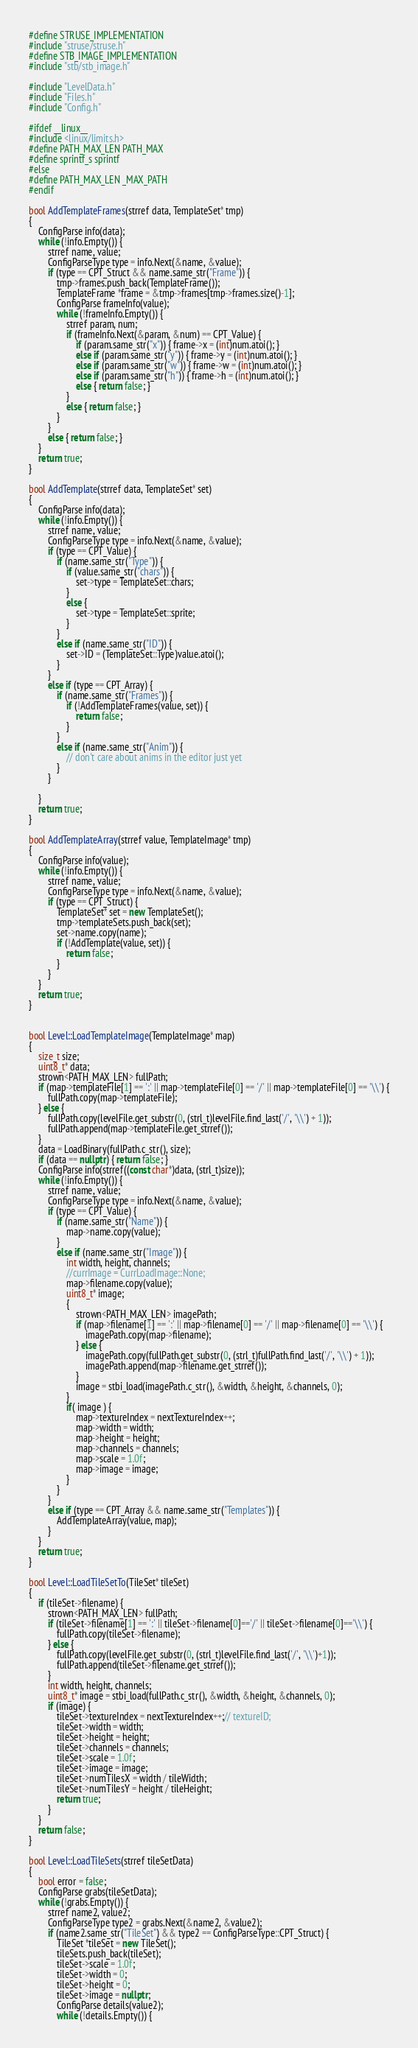<code> <loc_0><loc_0><loc_500><loc_500><_C++_>#define STRUSE_IMPLEMENTATION
#include "struse/struse.h"
#define STB_IMAGE_IMPLEMENTATION
#include "stb/stb_image.h"

#include "LevelData.h"
#include "Files.h"
#include "Config.h"

#ifdef __linux__
#include <linux/limits.h>
#define PATH_MAX_LEN PATH_MAX
#define sprintf_s sprintf
#else
#define PATH_MAX_LEN _MAX_PATH
#endif

bool AddTemplateFrames(strref data, TemplateSet* tmp)
{
	ConfigParse info(data);
	while (!info.Empty()) {
		strref name, value;
		ConfigParseType type = info.Next(&name, &value);
		if (type == CPT_Struct && name.same_str("Frame")) {
			tmp->frames.push_back(TemplateFrame());
			TemplateFrame *frame = &tmp->frames[tmp->frames.size()-1];
			ConfigParse frameInfo(value);
			while (!frameInfo.Empty()) {
				strref param, num;
				if (frameInfo.Next(&param, &num) == CPT_Value) {
					if (param.same_str("x")) { frame->x = (int)num.atoi(); }
					else if (param.same_str("y")) { frame->y = (int)num.atoi(); }
					else if (param.same_str("w")) { frame->w = (int)num.atoi(); }
					else if (param.same_str("h")) { frame->h = (int)num.atoi(); }
					else { return false; }
				}
				else { return false; }
			}
		}
		else { return false; }
	}
	return true;
}

bool AddTemplate(strref data, TemplateSet* set)
{
	ConfigParse info(data);
	while (!info.Empty()) {
		strref name, value;
		ConfigParseType type = info.Next(&name, &value);
		if (type == CPT_Value) {
			if (name.same_str("Type")) {
				if (value.same_str("chars")) {
					set->type = TemplateSet::chars;
				}
				else {
					set->type = TemplateSet::sprite;
				}
			}
			else if (name.same_str("ID")) {
				set->ID = (TemplateSet::Type)value.atoi();
			}
		}
		else if (type == CPT_Array) {
			if (name.same_str("Frames")) {
				if (!AddTemplateFrames(value, set)) {
					return false;
				}
			}
			else if (name.same_str("Anim")) {
				// don't care about anims in the editor just yet
			}
		}

	}
	return true;
}

bool AddTemplateArray(strref value, TemplateImage* tmp)
{
	ConfigParse info(value);
	while (!info.Empty()) {
		strref name, value;
		ConfigParseType type = info.Next(&name, &value);
		if (type == CPT_Struct) {
			TemplateSet* set = new TemplateSet();
			tmp->templateSets.push_back(set);
			set->name.copy(name);
			if (!AddTemplate(value, set)) {
				return false;
			}
		}
	}
	return true;
}


bool Level::LoadTemplateImage(TemplateImage* map)
{
	size_t size;
	uint8_t* data;
	strown<PATH_MAX_LEN> fullPath;
	if (map->templateFile[1] == ':' || map->templateFile[0] == '/' || map->templateFile[0] == '\\') {
		fullPath.copy(map->templateFile);
	} else {
		fullPath.copy(levelFile.get_substr(0, (strl_t)levelFile.find_last('/', '\\') + 1));
		fullPath.append(map->templateFile.get_strref());
	}
	data = LoadBinary(fullPath.c_str(), size);
	if (data == nullptr) { return false; }
	ConfigParse info(strref((const char*)data, (strl_t)size));
	while (!info.Empty()) {
		strref name, value;
		ConfigParseType type = info.Next(&name, &value);
		if (type == CPT_Value) {
			if (name.same_str("Name")) {
				map->name.copy(value);
			}
			else if (name.same_str("Image")) {
				int width, height, channels;
				//currImage = CurrLoadImage::None;
				map->filename.copy(value);
				uint8_t* image;
				{
					strown<PATH_MAX_LEN> imagePath;
					if (map->filename[1] == ':' || map->filename[0] == '/' || map->filename[0] == '\\') {
						imagePath.copy(map->filename);
					} else {
						imagePath.copy(fullPath.get_substr(0, (strl_t)fullPath.find_last('/', '\\') + 1));
						imagePath.append(map->filename.get_strref());
					}
					image = stbi_load(imagePath.c_str(), &width, &height, &channels, 0);
				}
				if( image ) {
					map->textureIndex = nextTextureIndex++;
					map->width = width;
					map->height = height;
					map->channels = channels;
					map->scale = 1.0f;
					map->image = image;
				}
			}
		}
		else if (type == CPT_Array && name.same_str("Templates")) {
			AddTemplateArray(value, map);
		}
	}
	return true;
}

bool Level::LoadTileSetTo(TileSet* tileSet)
{
	if (tileSet->filename) {
		strown<PATH_MAX_LEN> fullPath;
		if (tileSet->filename[1] == ':' || tileSet->filename[0]=='/' || tileSet->filename[0]=='\\') {
			fullPath.copy(tileSet->filename);
		} else {
			fullPath.copy(levelFile.get_substr(0, (strl_t)levelFile.find_last('/', '\\')+1));
			fullPath.append(tileSet->filename.get_strref());
		}
		int width, height, channels;
		uint8_t* image = stbi_load(fullPath.c_str(), &width, &height, &channels, 0);
		if (image) {
			tileSet->textureIndex = nextTextureIndex++;// textureID;
			tileSet->width = width;
			tileSet->height = height;
			tileSet->channels = channels;
			tileSet->scale = 1.0f;
			tileSet->image = image;
			tileSet->numTilesX = width / tileWidth;
			tileSet->numTilesY = height / tileHeight;
			return true;
		}
	}
	return false;
}

bool Level::LoadTileSets(strref tileSetData)
{
	bool error = false;
	ConfigParse grabs(tileSetData);
	while (!grabs.Empty()) {
		strref name2, value2;
		ConfigParseType type2 = grabs.Next(&name2, &value2);
		if (name2.same_str("TileSet") && type2 == ConfigParseType::CPT_Struct) {
			TileSet *tileSet = new TileSet();
			tileSets.push_back(tileSet);
			tileSet->scale = 1.0f;
			tileSet->width = 0;
			tileSet->height = 0;
			tileSet->image = nullptr;
			ConfigParse details(value2);
			while (!details.Empty()) {</code> 